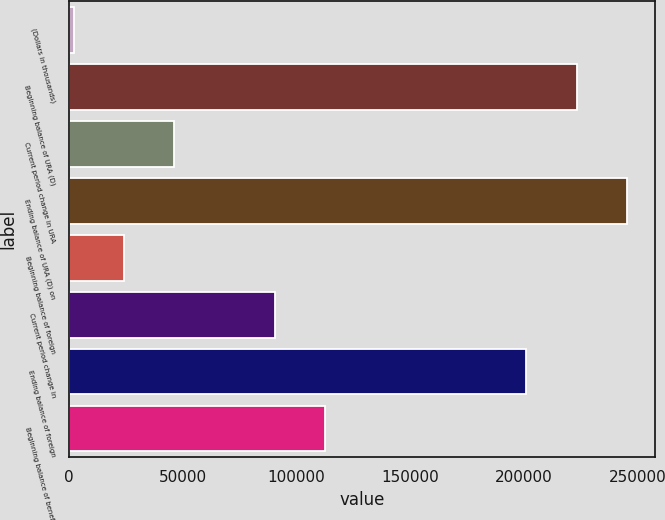Convert chart. <chart><loc_0><loc_0><loc_500><loc_500><bar_chart><fcel>(Dollars in thousands)<fcel>Beginning balance of URA (D)<fcel>Current period change in URA<fcel>Ending balance of URA (D) on<fcel>Beginning balance of foreign<fcel>Current period change in<fcel>Ending balance of foreign<fcel>Beginning balance of benefit<nl><fcel>2014<fcel>223250<fcel>46261.2<fcel>245374<fcel>24137.6<fcel>90508.4<fcel>201126<fcel>112632<nl></chart> 